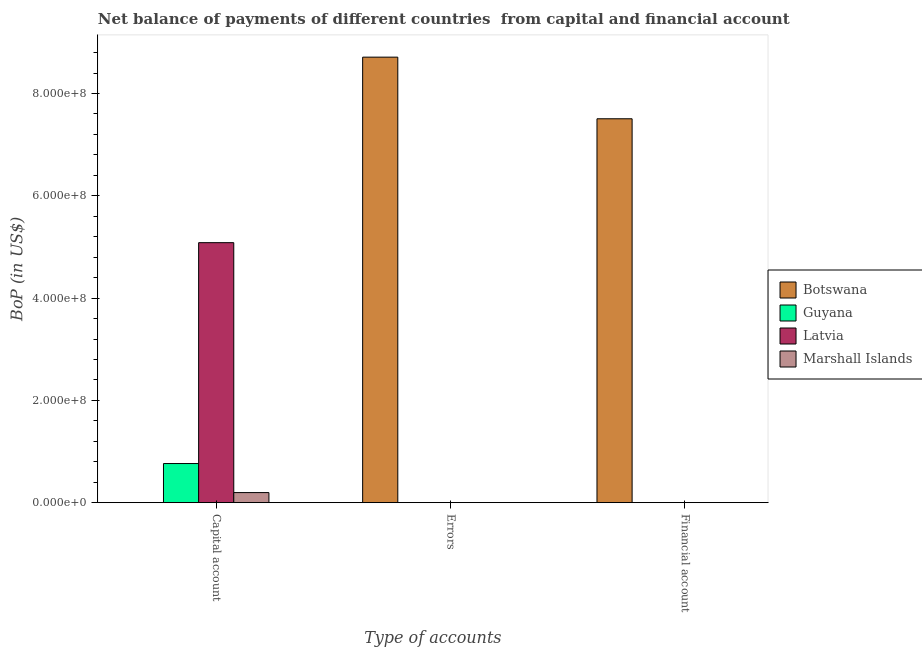How many bars are there on the 3rd tick from the right?
Your response must be concise. 3. What is the label of the 3rd group of bars from the left?
Offer a terse response. Financial account. What is the amount of errors in Botswana?
Provide a succinct answer. 8.71e+08. Across all countries, what is the maximum amount of financial account?
Your answer should be very brief. 7.51e+08. In which country was the amount of financial account maximum?
Your answer should be compact. Botswana. What is the total amount of errors in the graph?
Offer a terse response. 8.71e+08. What is the difference between the amount of financial account in Guyana and the amount of errors in Botswana?
Make the answer very short. -8.71e+08. What is the average amount of net capital account per country?
Your answer should be very brief. 1.51e+08. In how many countries, is the amount of financial account greater than 520000000 US$?
Offer a very short reply. 1. What is the ratio of the amount of net capital account in Marshall Islands to that in Latvia?
Keep it short and to the point. 0.04. What is the difference between the highest and the second highest amount of net capital account?
Ensure brevity in your answer.  4.32e+08. What is the difference between the highest and the lowest amount of net capital account?
Provide a short and direct response. 5.08e+08. Is it the case that in every country, the sum of the amount of net capital account and amount of errors is greater than the amount of financial account?
Your response must be concise. Yes. Does the graph contain grids?
Your response must be concise. No. How many legend labels are there?
Provide a succinct answer. 4. What is the title of the graph?
Provide a succinct answer. Net balance of payments of different countries  from capital and financial account. Does "Iraq" appear as one of the legend labels in the graph?
Offer a very short reply. No. What is the label or title of the X-axis?
Your answer should be very brief. Type of accounts. What is the label or title of the Y-axis?
Ensure brevity in your answer.  BoP (in US$). What is the BoP (in US$) of Guyana in Capital account?
Keep it short and to the point. 7.65e+07. What is the BoP (in US$) of Latvia in Capital account?
Your response must be concise. 5.08e+08. What is the BoP (in US$) of Marshall Islands in Capital account?
Offer a very short reply. 1.97e+07. What is the BoP (in US$) in Botswana in Errors?
Provide a succinct answer. 8.71e+08. What is the BoP (in US$) of Guyana in Errors?
Keep it short and to the point. 0. What is the BoP (in US$) in Latvia in Errors?
Keep it short and to the point. 0. What is the BoP (in US$) in Botswana in Financial account?
Give a very brief answer. 7.51e+08. What is the BoP (in US$) in Guyana in Financial account?
Your answer should be compact. 0. What is the BoP (in US$) of Latvia in Financial account?
Ensure brevity in your answer.  0. What is the BoP (in US$) in Marshall Islands in Financial account?
Ensure brevity in your answer.  0. Across all Type of accounts, what is the maximum BoP (in US$) in Botswana?
Provide a short and direct response. 8.71e+08. Across all Type of accounts, what is the maximum BoP (in US$) of Guyana?
Your answer should be very brief. 7.65e+07. Across all Type of accounts, what is the maximum BoP (in US$) of Latvia?
Give a very brief answer. 5.08e+08. Across all Type of accounts, what is the maximum BoP (in US$) of Marshall Islands?
Your response must be concise. 1.97e+07. Across all Type of accounts, what is the minimum BoP (in US$) in Botswana?
Your answer should be compact. 0. Across all Type of accounts, what is the minimum BoP (in US$) in Guyana?
Provide a short and direct response. 0. What is the total BoP (in US$) of Botswana in the graph?
Offer a terse response. 1.62e+09. What is the total BoP (in US$) of Guyana in the graph?
Offer a terse response. 7.65e+07. What is the total BoP (in US$) of Latvia in the graph?
Keep it short and to the point. 5.08e+08. What is the total BoP (in US$) in Marshall Islands in the graph?
Your response must be concise. 1.97e+07. What is the difference between the BoP (in US$) in Botswana in Errors and that in Financial account?
Keep it short and to the point. 1.20e+08. What is the average BoP (in US$) in Botswana per Type of accounts?
Give a very brief answer. 5.41e+08. What is the average BoP (in US$) of Guyana per Type of accounts?
Give a very brief answer. 2.55e+07. What is the average BoP (in US$) of Latvia per Type of accounts?
Your response must be concise. 1.69e+08. What is the average BoP (in US$) of Marshall Islands per Type of accounts?
Offer a terse response. 6.56e+06. What is the difference between the BoP (in US$) in Guyana and BoP (in US$) in Latvia in Capital account?
Give a very brief answer. -4.32e+08. What is the difference between the BoP (in US$) in Guyana and BoP (in US$) in Marshall Islands in Capital account?
Provide a succinct answer. 5.68e+07. What is the difference between the BoP (in US$) of Latvia and BoP (in US$) of Marshall Islands in Capital account?
Your response must be concise. 4.89e+08. What is the ratio of the BoP (in US$) of Botswana in Errors to that in Financial account?
Provide a succinct answer. 1.16. What is the difference between the highest and the lowest BoP (in US$) of Botswana?
Your answer should be very brief. 8.71e+08. What is the difference between the highest and the lowest BoP (in US$) of Guyana?
Your answer should be compact. 7.65e+07. What is the difference between the highest and the lowest BoP (in US$) in Latvia?
Your response must be concise. 5.08e+08. What is the difference between the highest and the lowest BoP (in US$) of Marshall Islands?
Keep it short and to the point. 1.97e+07. 